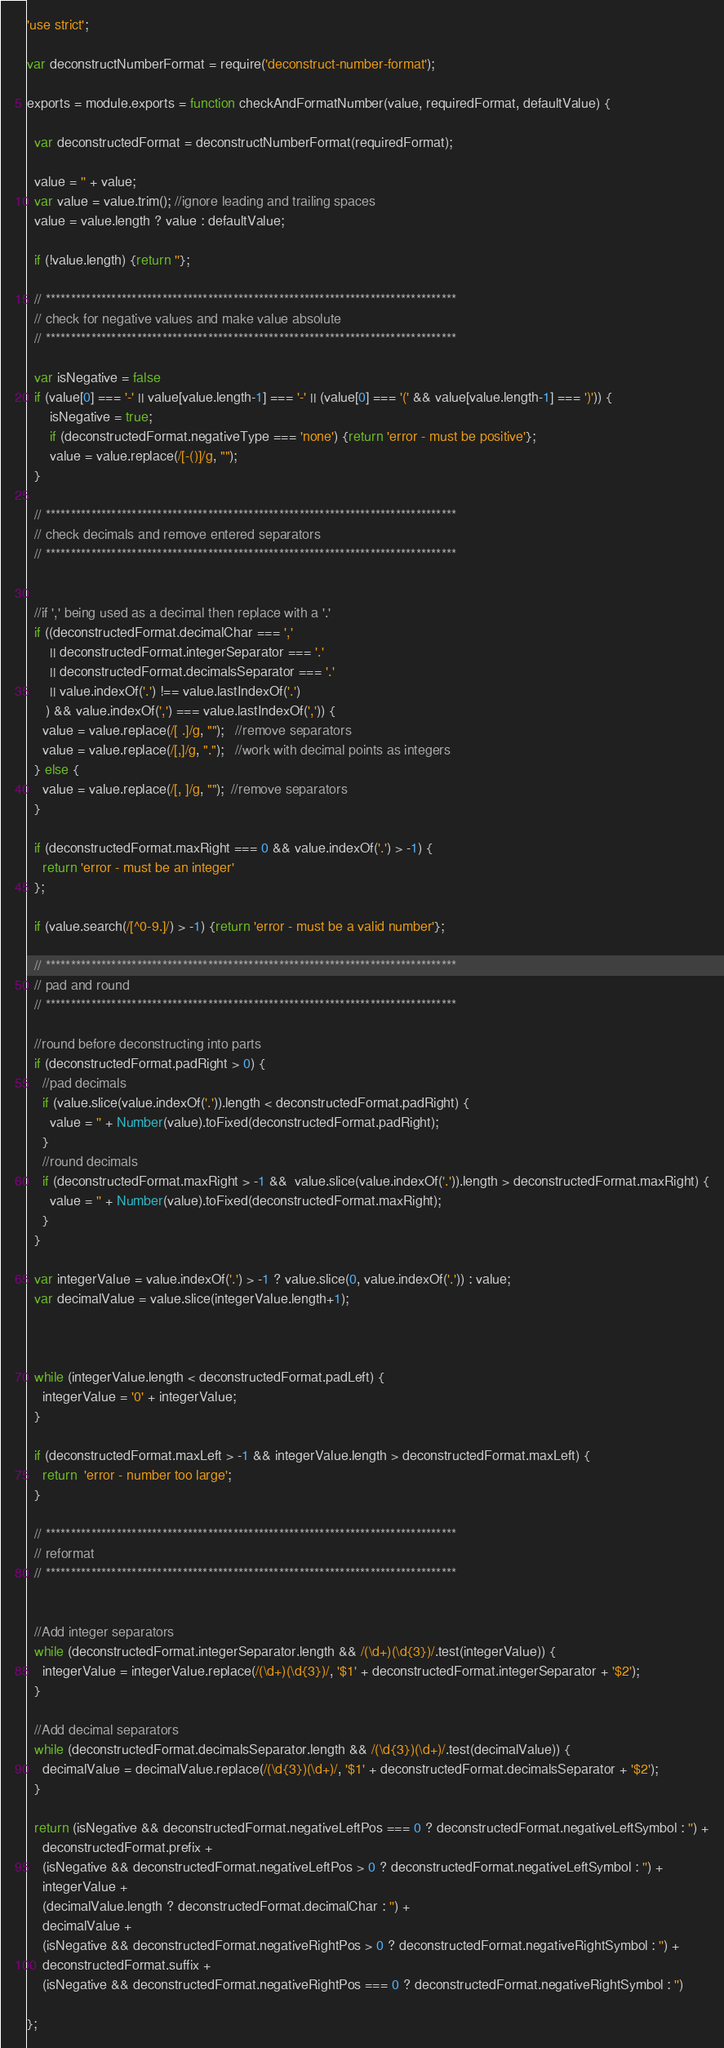<code> <loc_0><loc_0><loc_500><loc_500><_JavaScript_>'use strict';

var deconstructNumberFormat = require('deconstruct-number-format');

exports = module.exports = function checkAndFormatNumber(value, requiredFormat, defaultValue) {

  var deconstructedFormat = deconstructNumberFormat(requiredFormat);

  value = '' + value;
  var value = value.trim(); //ignore leading and trailing spaces
  value = value.length ? value : defaultValue;
  
  if (!value.length) {return ''};
  
  // *********************************************************************************
  // check for negative values and make value absolute
  // *********************************************************************************

  var isNegative = false
  if (value[0] === '-' || value[value.length-1] === '-' || (value[0] === '(' && value[value.length-1] === ')')) {
      isNegative = true;
      if (deconstructedFormat.negativeType === 'none') {return 'error - must be positive'};
      value = value.replace(/[-()]/g, "");
  }

  // *********************************************************************************
  // check decimals and remove entered separators
  // *********************************************************************************


  //if ',' being used as a decimal then replace with a '.'
  if ((deconstructedFormat.decimalChar === ','
      || deconstructedFormat.integerSeparator === '.'
      || deconstructedFormat.decimalsSeparator === '.'
      || value.indexOf('.') !== value.lastIndexOf('.')
     ) && value.indexOf(',') === value.lastIndexOf(',')) {
    value = value.replace(/[ .]/g, "");   //remove separators
    value = value.replace(/[,]/g, ".");   //work with decimal points as integers
  } else {
    value = value.replace(/[, ]/g, "");  //remove separators
  }

  if (deconstructedFormat.maxRight === 0 && value.indexOf('.') > -1) {
    return 'error - must be an integer'
  };

  if (value.search(/[^0-9.]/) > -1) {return 'error - must be a valid number'};

  // *********************************************************************************
  // pad and round
  // *********************************************************************************

  //round before deconstructing into parts
  if (deconstructedFormat.padRight > 0) {
    //pad decimals
    if (value.slice(value.indexOf('.')).length < deconstructedFormat.padRight) {
      value = '' + Number(value).toFixed(deconstructedFormat.padRight);
    }
    //round decimals
    if (deconstructedFormat.maxRight > -1 &&  value.slice(value.indexOf('.')).length > deconstructedFormat.maxRight) {
      value = '' + Number(value).toFixed(deconstructedFormat.maxRight);
    }
  }
  
  var integerValue = value.indexOf('.') > -1 ? value.slice(0, value.indexOf('.')) : value;
  var decimalValue = value.slice(integerValue.length+1);


  
  while (integerValue.length < deconstructedFormat.padLeft) {
    integerValue = '0' + integerValue;
  }

  if (deconstructedFormat.maxLeft > -1 && integerValue.length > deconstructedFormat.maxLeft) {
    return  'error - number too large';
  }

  // *********************************************************************************
  // reformat
  // *********************************************************************************

  
  //Add integer separators
  while (deconstructedFormat.integerSeparator.length && /(\d+)(\d{3})/.test(integerValue)) {
    integerValue = integerValue.replace(/(\d+)(\d{3})/, '$1' + deconstructedFormat.integerSeparator + '$2');
  }

  //Add decimal separators
  while (deconstructedFormat.decimalsSeparator.length && /(\d{3})(\d+)/.test(decimalValue)) {
    decimalValue = decimalValue.replace(/(\d{3})(\d+)/, '$1' + deconstructedFormat.decimalsSeparator + '$2');
  }

  return (isNegative && deconstructedFormat.negativeLeftPos === 0 ? deconstructedFormat.negativeLeftSymbol : '') +
    deconstructedFormat.prefix +
    (isNegative && deconstructedFormat.negativeLeftPos > 0 ? deconstructedFormat.negativeLeftSymbol : '') +
    integerValue +
    (decimalValue.length ? deconstructedFormat.decimalChar : '') +
    decimalValue +
    (isNegative && deconstructedFormat.negativeRightPos > 0 ? deconstructedFormat.negativeRightSymbol : '') +
    deconstructedFormat.suffix +
    (isNegative && deconstructedFormat.negativeRightPos === 0 ? deconstructedFormat.negativeRightSymbol : '')

};</code> 